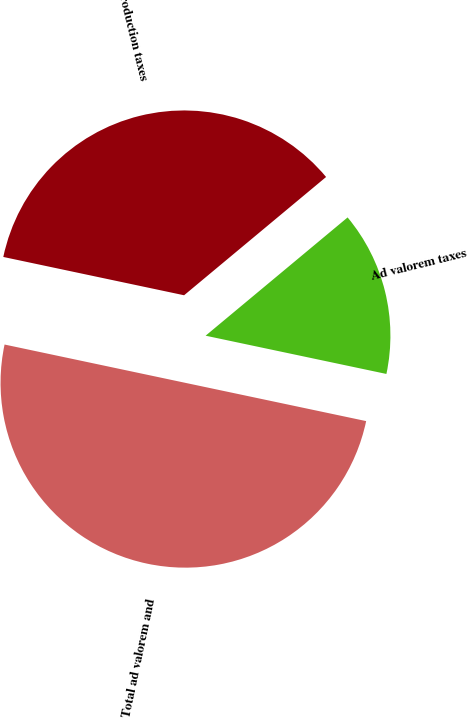Convert chart. <chart><loc_0><loc_0><loc_500><loc_500><pie_chart><fcel>Production taxes<fcel>Ad valorem taxes<fcel>Total ad valorem and<nl><fcel>35.62%<fcel>14.37%<fcel>50.0%<nl></chart> 